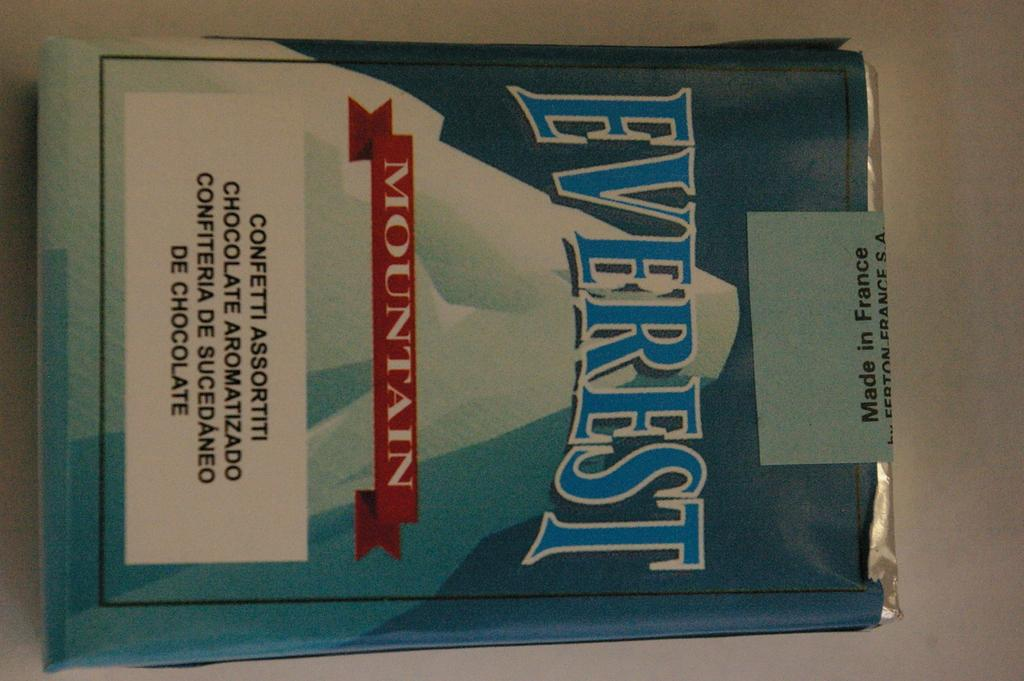<image>
Describe the image concisely. a new unopened pack of everest mountain branded cigarettes. 